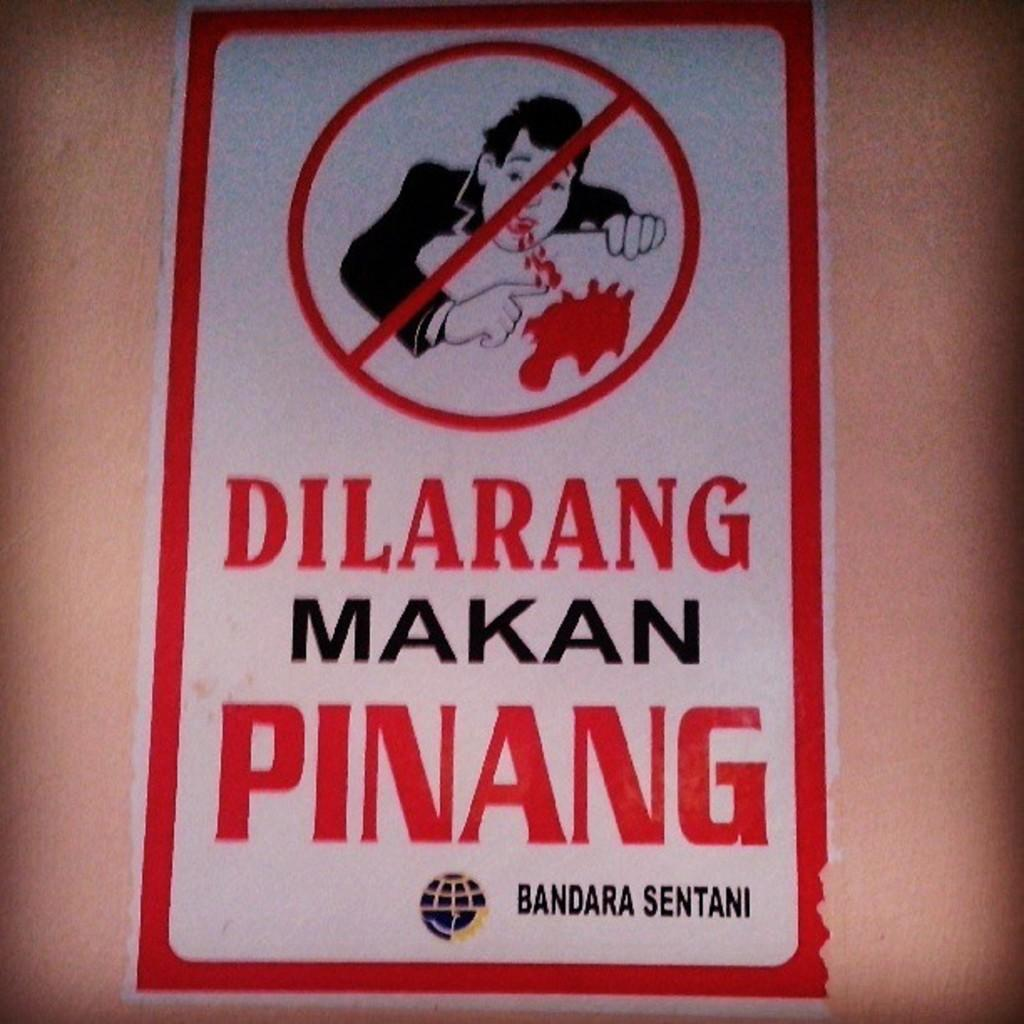<image>
Share a concise interpretation of the image provided. A painted sign with the warning of "Dilarang Makan Pinang". 